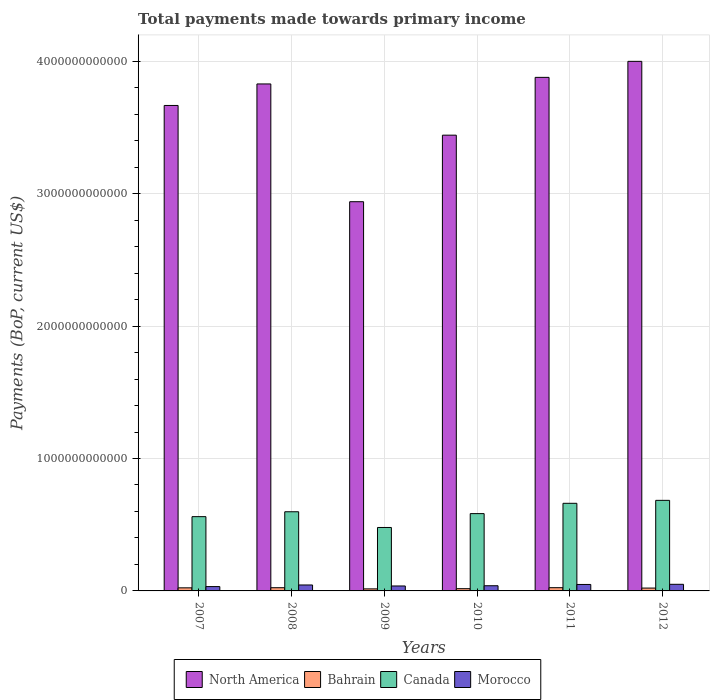How many different coloured bars are there?
Ensure brevity in your answer.  4. How many groups of bars are there?
Provide a short and direct response. 6. Are the number of bars per tick equal to the number of legend labels?
Make the answer very short. Yes. What is the total payments made towards primary income in Canada in 2007?
Ensure brevity in your answer.  5.61e+11. Across all years, what is the maximum total payments made towards primary income in Bahrain?
Provide a short and direct response. 2.45e+1. Across all years, what is the minimum total payments made towards primary income in North America?
Offer a terse response. 2.94e+12. In which year was the total payments made towards primary income in Canada maximum?
Provide a succinct answer. 2012. What is the total total payments made towards primary income in Morocco in the graph?
Provide a succinct answer. 2.53e+11. What is the difference between the total payments made towards primary income in North America in 2009 and that in 2011?
Provide a succinct answer. -9.39e+11. What is the difference between the total payments made towards primary income in Morocco in 2007 and the total payments made towards primary income in North America in 2012?
Give a very brief answer. -3.97e+12. What is the average total payments made towards primary income in Morocco per year?
Your response must be concise. 4.21e+1. In the year 2011, what is the difference between the total payments made towards primary income in Morocco and total payments made towards primary income in Canada?
Your answer should be very brief. -6.13e+11. What is the ratio of the total payments made towards primary income in North America in 2009 to that in 2012?
Make the answer very short. 0.73. Is the difference between the total payments made towards primary income in Morocco in 2007 and 2008 greater than the difference between the total payments made towards primary income in Canada in 2007 and 2008?
Offer a very short reply. Yes. What is the difference between the highest and the second highest total payments made towards primary income in Morocco?
Give a very brief answer. 1.15e+09. What is the difference between the highest and the lowest total payments made towards primary income in Bahrain?
Make the answer very short. 9.04e+09. In how many years, is the total payments made towards primary income in Canada greater than the average total payments made towards primary income in Canada taken over all years?
Offer a very short reply. 3. Is it the case that in every year, the sum of the total payments made towards primary income in Morocco and total payments made towards primary income in North America is greater than the sum of total payments made towards primary income in Bahrain and total payments made towards primary income in Canada?
Keep it short and to the point. Yes. What does the 3rd bar from the left in 2008 represents?
Offer a very short reply. Canada. What does the 2nd bar from the right in 2010 represents?
Offer a very short reply. Canada. Is it the case that in every year, the sum of the total payments made towards primary income in Bahrain and total payments made towards primary income in Canada is greater than the total payments made towards primary income in Morocco?
Give a very brief answer. Yes. How many bars are there?
Ensure brevity in your answer.  24. Are all the bars in the graph horizontal?
Give a very brief answer. No. What is the difference between two consecutive major ticks on the Y-axis?
Provide a succinct answer. 1.00e+12. Are the values on the major ticks of Y-axis written in scientific E-notation?
Your response must be concise. No. How are the legend labels stacked?
Your response must be concise. Horizontal. What is the title of the graph?
Provide a succinct answer. Total payments made towards primary income. Does "Morocco" appear as one of the legend labels in the graph?
Ensure brevity in your answer.  Yes. What is the label or title of the Y-axis?
Ensure brevity in your answer.  Payments (BoP, current US$). What is the Payments (BoP, current US$) of North America in 2007?
Your response must be concise. 3.67e+12. What is the Payments (BoP, current US$) of Bahrain in 2007?
Offer a very short reply. 2.33e+1. What is the Payments (BoP, current US$) of Canada in 2007?
Offer a very short reply. 5.61e+11. What is the Payments (BoP, current US$) of Morocco in 2007?
Your answer should be very brief. 3.27e+1. What is the Payments (BoP, current US$) of North America in 2008?
Give a very brief answer. 3.83e+12. What is the Payments (BoP, current US$) in Bahrain in 2008?
Provide a short and direct response. 2.43e+1. What is the Payments (BoP, current US$) in Canada in 2008?
Your answer should be very brief. 5.98e+11. What is the Payments (BoP, current US$) in Morocco in 2008?
Provide a short and direct response. 4.49e+1. What is the Payments (BoP, current US$) of North America in 2009?
Offer a terse response. 2.94e+12. What is the Payments (BoP, current US$) of Bahrain in 2009?
Provide a short and direct response. 1.54e+1. What is the Payments (BoP, current US$) of Canada in 2009?
Make the answer very short. 4.79e+11. What is the Payments (BoP, current US$) in Morocco in 2009?
Provide a succinct answer. 3.73e+1. What is the Payments (BoP, current US$) of North America in 2010?
Your answer should be compact. 3.44e+12. What is the Payments (BoP, current US$) in Bahrain in 2010?
Make the answer very short. 1.69e+1. What is the Payments (BoP, current US$) in Canada in 2010?
Your answer should be compact. 5.84e+11. What is the Payments (BoP, current US$) in Morocco in 2010?
Make the answer very short. 3.91e+1. What is the Payments (BoP, current US$) of North America in 2011?
Offer a very short reply. 3.88e+12. What is the Payments (BoP, current US$) of Bahrain in 2011?
Your answer should be compact. 2.45e+1. What is the Payments (BoP, current US$) of Canada in 2011?
Your answer should be compact. 6.62e+11. What is the Payments (BoP, current US$) in Morocco in 2011?
Your answer should be compact. 4.88e+1. What is the Payments (BoP, current US$) in North America in 2012?
Keep it short and to the point. 4.00e+12. What is the Payments (BoP, current US$) of Bahrain in 2012?
Your answer should be very brief. 2.16e+1. What is the Payments (BoP, current US$) in Canada in 2012?
Offer a terse response. 6.84e+11. What is the Payments (BoP, current US$) of Morocco in 2012?
Offer a terse response. 4.99e+1. Across all years, what is the maximum Payments (BoP, current US$) of North America?
Your answer should be very brief. 4.00e+12. Across all years, what is the maximum Payments (BoP, current US$) of Bahrain?
Offer a very short reply. 2.45e+1. Across all years, what is the maximum Payments (BoP, current US$) of Canada?
Provide a succinct answer. 6.84e+11. Across all years, what is the maximum Payments (BoP, current US$) of Morocco?
Ensure brevity in your answer.  4.99e+1. Across all years, what is the minimum Payments (BoP, current US$) of North America?
Offer a very short reply. 2.94e+12. Across all years, what is the minimum Payments (BoP, current US$) of Bahrain?
Make the answer very short. 1.54e+1. Across all years, what is the minimum Payments (BoP, current US$) of Canada?
Give a very brief answer. 4.79e+11. Across all years, what is the minimum Payments (BoP, current US$) in Morocco?
Provide a succinct answer. 3.27e+1. What is the total Payments (BoP, current US$) of North America in the graph?
Keep it short and to the point. 2.18e+13. What is the total Payments (BoP, current US$) in Bahrain in the graph?
Provide a succinct answer. 1.26e+11. What is the total Payments (BoP, current US$) of Canada in the graph?
Your response must be concise. 3.57e+12. What is the total Payments (BoP, current US$) of Morocco in the graph?
Your answer should be very brief. 2.53e+11. What is the difference between the Payments (BoP, current US$) of North America in 2007 and that in 2008?
Your response must be concise. -1.62e+11. What is the difference between the Payments (BoP, current US$) in Bahrain in 2007 and that in 2008?
Your answer should be compact. -9.89e+08. What is the difference between the Payments (BoP, current US$) of Canada in 2007 and that in 2008?
Your answer should be compact. -3.69e+1. What is the difference between the Payments (BoP, current US$) of Morocco in 2007 and that in 2008?
Provide a short and direct response. -1.22e+1. What is the difference between the Payments (BoP, current US$) of North America in 2007 and that in 2009?
Offer a terse response. 7.27e+11. What is the difference between the Payments (BoP, current US$) of Bahrain in 2007 and that in 2009?
Your response must be concise. 7.86e+09. What is the difference between the Payments (BoP, current US$) of Canada in 2007 and that in 2009?
Provide a short and direct response. 8.17e+1. What is the difference between the Payments (BoP, current US$) of Morocco in 2007 and that in 2009?
Offer a terse response. -4.61e+09. What is the difference between the Payments (BoP, current US$) in North America in 2007 and that in 2010?
Your answer should be very brief. 2.24e+11. What is the difference between the Payments (BoP, current US$) of Bahrain in 2007 and that in 2010?
Provide a short and direct response. 6.36e+09. What is the difference between the Payments (BoP, current US$) in Canada in 2007 and that in 2010?
Your response must be concise. -2.29e+1. What is the difference between the Payments (BoP, current US$) of Morocco in 2007 and that in 2010?
Make the answer very short. -6.37e+09. What is the difference between the Payments (BoP, current US$) in North America in 2007 and that in 2011?
Your answer should be compact. -2.12e+11. What is the difference between the Payments (BoP, current US$) of Bahrain in 2007 and that in 2011?
Your answer should be very brief. -1.17e+09. What is the difference between the Payments (BoP, current US$) in Canada in 2007 and that in 2011?
Offer a terse response. -1.01e+11. What is the difference between the Payments (BoP, current US$) of Morocco in 2007 and that in 2011?
Your answer should be very brief. -1.60e+1. What is the difference between the Payments (BoP, current US$) in North America in 2007 and that in 2012?
Your answer should be compact. -3.33e+11. What is the difference between the Payments (BoP, current US$) in Bahrain in 2007 and that in 2012?
Your answer should be compact. 1.74e+09. What is the difference between the Payments (BoP, current US$) of Canada in 2007 and that in 2012?
Ensure brevity in your answer.  -1.23e+11. What is the difference between the Payments (BoP, current US$) of Morocco in 2007 and that in 2012?
Your answer should be compact. -1.72e+1. What is the difference between the Payments (BoP, current US$) of North America in 2008 and that in 2009?
Ensure brevity in your answer.  8.89e+11. What is the difference between the Payments (BoP, current US$) in Bahrain in 2008 and that in 2009?
Make the answer very short. 8.85e+09. What is the difference between the Payments (BoP, current US$) of Canada in 2008 and that in 2009?
Provide a succinct answer. 1.19e+11. What is the difference between the Payments (BoP, current US$) in Morocco in 2008 and that in 2009?
Ensure brevity in your answer.  7.56e+09. What is the difference between the Payments (BoP, current US$) of North America in 2008 and that in 2010?
Give a very brief answer. 3.87e+11. What is the difference between the Payments (BoP, current US$) of Bahrain in 2008 and that in 2010?
Your response must be concise. 7.35e+09. What is the difference between the Payments (BoP, current US$) of Canada in 2008 and that in 2010?
Your answer should be very brief. 1.40e+1. What is the difference between the Payments (BoP, current US$) in Morocco in 2008 and that in 2010?
Make the answer very short. 5.80e+09. What is the difference between the Payments (BoP, current US$) of North America in 2008 and that in 2011?
Make the answer very short. -4.97e+1. What is the difference between the Payments (BoP, current US$) of Bahrain in 2008 and that in 2011?
Make the answer very short. -1.82e+08. What is the difference between the Payments (BoP, current US$) in Canada in 2008 and that in 2011?
Your response must be concise. -6.38e+1. What is the difference between the Payments (BoP, current US$) in Morocco in 2008 and that in 2011?
Your response must be concise. -3.85e+09. What is the difference between the Payments (BoP, current US$) in North America in 2008 and that in 2012?
Offer a terse response. -1.71e+11. What is the difference between the Payments (BoP, current US$) of Bahrain in 2008 and that in 2012?
Offer a very short reply. 2.73e+09. What is the difference between the Payments (BoP, current US$) in Canada in 2008 and that in 2012?
Provide a succinct answer. -8.62e+1. What is the difference between the Payments (BoP, current US$) of Morocco in 2008 and that in 2012?
Ensure brevity in your answer.  -5.00e+09. What is the difference between the Payments (BoP, current US$) in North America in 2009 and that in 2010?
Your answer should be compact. -5.02e+11. What is the difference between the Payments (BoP, current US$) in Bahrain in 2009 and that in 2010?
Keep it short and to the point. -1.50e+09. What is the difference between the Payments (BoP, current US$) of Canada in 2009 and that in 2010?
Ensure brevity in your answer.  -1.05e+11. What is the difference between the Payments (BoP, current US$) in Morocco in 2009 and that in 2010?
Your response must be concise. -1.76e+09. What is the difference between the Payments (BoP, current US$) in North America in 2009 and that in 2011?
Your answer should be compact. -9.39e+11. What is the difference between the Payments (BoP, current US$) in Bahrain in 2009 and that in 2011?
Keep it short and to the point. -9.04e+09. What is the difference between the Payments (BoP, current US$) in Canada in 2009 and that in 2011?
Provide a succinct answer. -1.82e+11. What is the difference between the Payments (BoP, current US$) in Morocco in 2009 and that in 2011?
Provide a succinct answer. -1.14e+1. What is the difference between the Payments (BoP, current US$) in North America in 2009 and that in 2012?
Offer a very short reply. -1.06e+12. What is the difference between the Payments (BoP, current US$) in Bahrain in 2009 and that in 2012?
Your answer should be compact. -6.12e+09. What is the difference between the Payments (BoP, current US$) in Canada in 2009 and that in 2012?
Give a very brief answer. -2.05e+11. What is the difference between the Payments (BoP, current US$) of Morocco in 2009 and that in 2012?
Your response must be concise. -1.26e+1. What is the difference between the Payments (BoP, current US$) of North America in 2010 and that in 2011?
Give a very brief answer. -4.37e+11. What is the difference between the Payments (BoP, current US$) in Bahrain in 2010 and that in 2011?
Ensure brevity in your answer.  -7.53e+09. What is the difference between the Payments (BoP, current US$) of Canada in 2010 and that in 2011?
Your answer should be very brief. -7.78e+1. What is the difference between the Payments (BoP, current US$) in Morocco in 2010 and that in 2011?
Your answer should be compact. -9.65e+09. What is the difference between the Payments (BoP, current US$) in North America in 2010 and that in 2012?
Your answer should be very brief. -5.57e+11. What is the difference between the Payments (BoP, current US$) of Bahrain in 2010 and that in 2012?
Your answer should be very brief. -4.62e+09. What is the difference between the Payments (BoP, current US$) in Canada in 2010 and that in 2012?
Make the answer very short. -1.00e+11. What is the difference between the Payments (BoP, current US$) in Morocco in 2010 and that in 2012?
Make the answer very short. -1.08e+1. What is the difference between the Payments (BoP, current US$) of North America in 2011 and that in 2012?
Keep it short and to the point. -1.21e+11. What is the difference between the Payments (BoP, current US$) of Bahrain in 2011 and that in 2012?
Provide a succinct answer. 2.92e+09. What is the difference between the Payments (BoP, current US$) of Canada in 2011 and that in 2012?
Give a very brief answer. -2.23e+1. What is the difference between the Payments (BoP, current US$) of Morocco in 2011 and that in 2012?
Provide a succinct answer. -1.15e+09. What is the difference between the Payments (BoP, current US$) of North America in 2007 and the Payments (BoP, current US$) of Bahrain in 2008?
Give a very brief answer. 3.64e+12. What is the difference between the Payments (BoP, current US$) in North America in 2007 and the Payments (BoP, current US$) in Canada in 2008?
Offer a very short reply. 3.07e+12. What is the difference between the Payments (BoP, current US$) of North America in 2007 and the Payments (BoP, current US$) of Morocco in 2008?
Provide a succinct answer. 3.62e+12. What is the difference between the Payments (BoP, current US$) in Bahrain in 2007 and the Payments (BoP, current US$) in Canada in 2008?
Provide a succinct answer. -5.74e+11. What is the difference between the Payments (BoP, current US$) in Bahrain in 2007 and the Payments (BoP, current US$) in Morocco in 2008?
Offer a terse response. -2.16e+1. What is the difference between the Payments (BoP, current US$) in Canada in 2007 and the Payments (BoP, current US$) in Morocco in 2008?
Make the answer very short. 5.16e+11. What is the difference between the Payments (BoP, current US$) of North America in 2007 and the Payments (BoP, current US$) of Bahrain in 2009?
Make the answer very short. 3.65e+12. What is the difference between the Payments (BoP, current US$) of North America in 2007 and the Payments (BoP, current US$) of Canada in 2009?
Your answer should be compact. 3.19e+12. What is the difference between the Payments (BoP, current US$) of North America in 2007 and the Payments (BoP, current US$) of Morocco in 2009?
Your answer should be compact. 3.63e+12. What is the difference between the Payments (BoP, current US$) of Bahrain in 2007 and the Payments (BoP, current US$) of Canada in 2009?
Your response must be concise. -4.56e+11. What is the difference between the Payments (BoP, current US$) in Bahrain in 2007 and the Payments (BoP, current US$) in Morocco in 2009?
Offer a very short reply. -1.40e+1. What is the difference between the Payments (BoP, current US$) of Canada in 2007 and the Payments (BoP, current US$) of Morocco in 2009?
Make the answer very short. 5.24e+11. What is the difference between the Payments (BoP, current US$) of North America in 2007 and the Payments (BoP, current US$) of Bahrain in 2010?
Your response must be concise. 3.65e+12. What is the difference between the Payments (BoP, current US$) of North America in 2007 and the Payments (BoP, current US$) of Canada in 2010?
Your answer should be compact. 3.08e+12. What is the difference between the Payments (BoP, current US$) of North America in 2007 and the Payments (BoP, current US$) of Morocco in 2010?
Make the answer very short. 3.63e+12. What is the difference between the Payments (BoP, current US$) of Bahrain in 2007 and the Payments (BoP, current US$) of Canada in 2010?
Offer a very short reply. -5.60e+11. What is the difference between the Payments (BoP, current US$) in Bahrain in 2007 and the Payments (BoP, current US$) in Morocco in 2010?
Keep it short and to the point. -1.58e+1. What is the difference between the Payments (BoP, current US$) of Canada in 2007 and the Payments (BoP, current US$) of Morocco in 2010?
Offer a terse response. 5.22e+11. What is the difference between the Payments (BoP, current US$) of North America in 2007 and the Payments (BoP, current US$) of Bahrain in 2011?
Your response must be concise. 3.64e+12. What is the difference between the Payments (BoP, current US$) in North America in 2007 and the Payments (BoP, current US$) in Canada in 2011?
Give a very brief answer. 3.00e+12. What is the difference between the Payments (BoP, current US$) of North America in 2007 and the Payments (BoP, current US$) of Morocco in 2011?
Provide a short and direct response. 3.62e+12. What is the difference between the Payments (BoP, current US$) of Bahrain in 2007 and the Payments (BoP, current US$) of Canada in 2011?
Your response must be concise. -6.38e+11. What is the difference between the Payments (BoP, current US$) of Bahrain in 2007 and the Payments (BoP, current US$) of Morocco in 2011?
Provide a succinct answer. -2.55e+1. What is the difference between the Payments (BoP, current US$) of Canada in 2007 and the Payments (BoP, current US$) of Morocco in 2011?
Provide a succinct answer. 5.12e+11. What is the difference between the Payments (BoP, current US$) of North America in 2007 and the Payments (BoP, current US$) of Bahrain in 2012?
Your answer should be very brief. 3.64e+12. What is the difference between the Payments (BoP, current US$) of North America in 2007 and the Payments (BoP, current US$) of Canada in 2012?
Ensure brevity in your answer.  2.98e+12. What is the difference between the Payments (BoP, current US$) in North America in 2007 and the Payments (BoP, current US$) in Morocco in 2012?
Your answer should be compact. 3.62e+12. What is the difference between the Payments (BoP, current US$) in Bahrain in 2007 and the Payments (BoP, current US$) in Canada in 2012?
Offer a very short reply. -6.61e+11. What is the difference between the Payments (BoP, current US$) of Bahrain in 2007 and the Payments (BoP, current US$) of Morocco in 2012?
Provide a succinct answer. -2.66e+1. What is the difference between the Payments (BoP, current US$) in Canada in 2007 and the Payments (BoP, current US$) in Morocco in 2012?
Your answer should be compact. 5.11e+11. What is the difference between the Payments (BoP, current US$) of North America in 2008 and the Payments (BoP, current US$) of Bahrain in 2009?
Make the answer very short. 3.81e+12. What is the difference between the Payments (BoP, current US$) in North America in 2008 and the Payments (BoP, current US$) in Canada in 2009?
Give a very brief answer. 3.35e+12. What is the difference between the Payments (BoP, current US$) in North America in 2008 and the Payments (BoP, current US$) in Morocco in 2009?
Keep it short and to the point. 3.79e+12. What is the difference between the Payments (BoP, current US$) of Bahrain in 2008 and the Payments (BoP, current US$) of Canada in 2009?
Offer a very short reply. -4.55e+11. What is the difference between the Payments (BoP, current US$) in Bahrain in 2008 and the Payments (BoP, current US$) in Morocco in 2009?
Offer a very short reply. -1.31e+1. What is the difference between the Payments (BoP, current US$) in Canada in 2008 and the Payments (BoP, current US$) in Morocco in 2009?
Make the answer very short. 5.60e+11. What is the difference between the Payments (BoP, current US$) of North America in 2008 and the Payments (BoP, current US$) of Bahrain in 2010?
Offer a very short reply. 3.81e+12. What is the difference between the Payments (BoP, current US$) in North America in 2008 and the Payments (BoP, current US$) in Canada in 2010?
Provide a short and direct response. 3.24e+12. What is the difference between the Payments (BoP, current US$) of North America in 2008 and the Payments (BoP, current US$) of Morocco in 2010?
Offer a terse response. 3.79e+12. What is the difference between the Payments (BoP, current US$) of Bahrain in 2008 and the Payments (BoP, current US$) of Canada in 2010?
Provide a short and direct response. -5.60e+11. What is the difference between the Payments (BoP, current US$) of Bahrain in 2008 and the Payments (BoP, current US$) of Morocco in 2010?
Ensure brevity in your answer.  -1.48e+1. What is the difference between the Payments (BoP, current US$) of Canada in 2008 and the Payments (BoP, current US$) of Morocco in 2010?
Your response must be concise. 5.59e+11. What is the difference between the Payments (BoP, current US$) in North America in 2008 and the Payments (BoP, current US$) in Bahrain in 2011?
Your answer should be compact. 3.80e+12. What is the difference between the Payments (BoP, current US$) of North America in 2008 and the Payments (BoP, current US$) of Canada in 2011?
Give a very brief answer. 3.17e+12. What is the difference between the Payments (BoP, current US$) of North America in 2008 and the Payments (BoP, current US$) of Morocco in 2011?
Your answer should be very brief. 3.78e+12. What is the difference between the Payments (BoP, current US$) of Bahrain in 2008 and the Payments (BoP, current US$) of Canada in 2011?
Provide a succinct answer. -6.37e+11. What is the difference between the Payments (BoP, current US$) of Bahrain in 2008 and the Payments (BoP, current US$) of Morocco in 2011?
Give a very brief answer. -2.45e+1. What is the difference between the Payments (BoP, current US$) of Canada in 2008 and the Payments (BoP, current US$) of Morocco in 2011?
Offer a terse response. 5.49e+11. What is the difference between the Payments (BoP, current US$) of North America in 2008 and the Payments (BoP, current US$) of Bahrain in 2012?
Give a very brief answer. 3.81e+12. What is the difference between the Payments (BoP, current US$) in North America in 2008 and the Payments (BoP, current US$) in Canada in 2012?
Your response must be concise. 3.14e+12. What is the difference between the Payments (BoP, current US$) of North America in 2008 and the Payments (BoP, current US$) of Morocco in 2012?
Your answer should be compact. 3.78e+12. What is the difference between the Payments (BoP, current US$) in Bahrain in 2008 and the Payments (BoP, current US$) in Canada in 2012?
Your answer should be compact. -6.60e+11. What is the difference between the Payments (BoP, current US$) in Bahrain in 2008 and the Payments (BoP, current US$) in Morocco in 2012?
Make the answer very short. -2.56e+1. What is the difference between the Payments (BoP, current US$) in Canada in 2008 and the Payments (BoP, current US$) in Morocco in 2012?
Make the answer very short. 5.48e+11. What is the difference between the Payments (BoP, current US$) of North America in 2009 and the Payments (BoP, current US$) of Bahrain in 2010?
Give a very brief answer. 2.92e+12. What is the difference between the Payments (BoP, current US$) in North America in 2009 and the Payments (BoP, current US$) in Canada in 2010?
Provide a short and direct response. 2.36e+12. What is the difference between the Payments (BoP, current US$) in North America in 2009 and the Payments (BoP, current US$) in Morocco in 2010?
Give a very brief answer. 2.90e+12. What is the difference between the Payments (BoP, current US$) in Bahrain in 2009 and the Payments (BoP, current US$) in Canada in 2010?
Your answer should be very brief. -5.68e+11. What is the difference between the Payments (BoP, current US$) of Bahrain in 2009 and the Payments (BoP, current US$) of Morocco in 2010?
Keep it short and to the point. -2.37e+1. What is the difference between the Payments (BoP, current US$) in Canada in 2009 and the Payments (BoP, current US$) in Morocco in 2010?
Offer a very short reply. 4.40e+11. What is the difference between the Payments (BoP, current US$) in North America in 2009 and the Payments (BoP, current US$) in Bahrain in 2011?
Provide a short and direct response. 2.91e+12. What is the difference between the Payments (BoP, current US$) of North America in 2009 and the Payments (BoP, current US$) of Canada in 2011?
Offer a terse response. 2.28e+12. What is the difference between the Payments (BoP, current US$) of North America in 2009 and the Payments (BoP, current US$) of Morocco in 2011?
Ensure brevity in your answer.  2.89e+12. What is the difference between the Payments (BoP, current US$) of Bahrain in 2009 and the Payments (BoP, current US$) of Canada in 2011?
Keep it short and to the point. -6.46e+11. What is the difference between the Payments (BoP, current US$) of Bahrain in 2009 and the Payments (BoP, current US$) of Morocco in 2011?
Give a very brief answer. -3.33e+1. What is the difference between the Payments (BoP, current US$) of Canada in 2009 and the Payments (BoP, current US$) of Morocco in 2011?
Provide a short and direct response. 4.30e+11. What is the difference between the Payments (BoP, current US$) of North America in 2009 and the Payments (BoP, current US$) of Bahrain in 2012?
Offer a terse response. 2.92e+12. What is the difference between the Payments (BoP, current US$) in North America in 2009 and the Payments (BoP, current US$) in Canada in 2012?
Your response must be concise. 2.26e+12. What is the difference between the Payments (BoP, current US$) in North America in 2009 and the Payments (BoP, current US$) in Morocco in 2012?
Keep it short and to the point. 2.89e+12. What is the difference between the Payments (BoP, current US$) in Bahrain in 2009 and the Payments (BoP, current US$) in Canada in 2012?
Your answer should be compact. -6.69e+11. What is the difference between the Payments (BoP, current US$) of Bahrain in 2009 and the Payments (BoP, current US$) of Morocco in 2012?
Your response must be concise. -3.45e+1. What is the difference between the Payments (BoP, current US$) of Canada in 2009 and the Payments (BoP, current US$) of Morocco in 2012?
Offer a terse response. 4.29e+11. What is the difference between the Payments (BoP, current US$) of North America in 2010 and the Payments (BoP, current US$) of Bahrain in 2011?
Give a very brief answer. 3.42e+12. What is the difference between the Payments (BoP, current US$) of North America in 2010 and the Payments (BoP, current US$) of Canada in 2011?
Keep it short and to the point. 2.78e+12. What is the difference between the Payments (BoP, current US$) in North America in 2010 and the Payments (BoP, current US$) in Morocco in 2011?
Ensure brevity in your answer.  3.39e+12. What is the difference between the Payments (BoP, current US$) in Bahrain in 2010 and the Payments (BoP, current US$) in Canada in 2011?
Make the answer very short. -6.45e+11. What is the difference between the Payments (BoP, current US$) in Bahrain in 2010 and the Payments (BoP, current US$) in Morocco in 2011?
Make the answer very short. -3.18e+1. What is the difference between the Payments (BoP, current US$) of Canada in 2010 and the Payments (BoP, current US$) of Morocco in 2011?
Your response must be concise. 5.35e+11. What is the difference between the Payments (BoP, current US$) in North America in 2010 and the Payments (BoP, current US$) in Bahrain in 2012?
Ensure brevity in your answer.  3.42e+12. What is the difference between the Payments (BoP, current US$) in North America in 2010 and the Payments (BoP, current US$) in Canada in 2012?
Give a very brief answer. 2.76e+12. What is the difference between the Payments (BoP, current US$) of North America in 2010 and the Payments (BoP, current US$) of Morocco in 2012?
Give a very brief answer. 3.39e+12. What is the difference between the Payments (BoP, current US$) of Bahrain in 2010 and the Payments (BoP, current US$) of Canada in 2012?
Ensure brevity in your answer.  -6.67e+11. What is the difference between the Payments (BoP, current US$) in Bahrain in 2010 and the Payments (BoP, current US$) in Morocco in 2012?
Provide a short and direct response. -3.30e+1. What is the difference between the Payments (BoP, current US$) of Canada in 2010 and the Payments (BoP, current US$) of Morocco in 2012?
Your answer should be very brief. 5.34e+11. What is the difference between the Payments (BoP, current US$) of North America in 2011 and the Payments (BoP, current US$) of Bahrain in 2012?
Your response must be concise. 3.86e+12. What is the difference between the Payments (BoP, current US$) of North America in 2011 and the Payments (BoP, current US$) of Canada in 2012?
Offer a very short reply. 3.19e+12. What is the difference between the Payments (BoP, current US$) in North America in 2011 and the Payments (BoP, current US$) in Morocco in 2012?
Provide a short and direct response. 3.83e+12. What is the difference between the Payments (BoP, current US$) of Bahrain in 2011 and the Payments (BoP, current US$) of Canada in 2012?
Your answer should be compact. -6.59e+11. What is the difference between the Payments (BoP, current US$) of Bahrain in 2011 and the Payments (BoP, current US$) of Morocco in 2012?
Ensure brevity in your answer.  -2.54e+1. What is the difference between the Payments (BoP, current US$) of Canada in 2011 and the Payments (BoP, current US$) of Morocco in 2012?
Your response must be concise. 6.12e+11. What is the average Payments (BoP, current US$) in North America per year?
Keep it short and to the point. 3.63e+12. What is the average Payments (BoP, current US$) in Bahrain per year?
Your answer should be compact. 2.10e+1. What is the average Payments (BoP, current US$) in Canada per year?
Your answer should be very brief. 5.95e+11. What is the average Payments (BoP, current US$) of Morocco per year?
Provide a short and direct response. 4.21e+1. In the year 2007, what is the difference between the Payments (BoP, current US$) of North America and Payments (BoP, current US$) of Bahrain?
Keep it short and to the point. 3.64e+12. In the year 2007, what is the difference between the Payments (BoP, current US$) in North America and Payments (BoP, current US$) in Canada?
Offer a terse response. 3.11e+12. In the year 2007, what is the difference between the Payments (BoP, current US$) in North America and Payments (BoP, current US$) in Morocco?
Ensure brevity in your answer.  3.63e+12. In the year 2007, what is the difference between the Payments (BoP, current US$) in Bahrain and Payments (BoP, current US$) in Canada?
Your response must be concise. -5.38e+11. In the year 2007, what is the difference between the Payments (BoP, current US$) in Bahrain and Payments (BoP, current US$) in Morocco?
Your response must be concise. -9.44e+09. In the year 2007, what is the difference between the Payments (BoP, current US$) of Canada and Payments (BoP, current US$) of Morocco?
Offer a terse response. 5.28e+11. In the year 2008, what is the difference between the Payments (BoP, current US$) in North America and Payments (BoP, current US$) in Bahrain?
Provide a succinct answer. 3.80e+12. In the year 2008, what is the difference between the Payments (BoP, current US$) in North America and Payments (BoP, current US$) in Canada?
Provide a succinct answer. 3.23e+12. In the year 2008, what is the difference between the Payments (BoP, current US$) in North America and Payments (BoP, current US$) in Morocco?
Offer a terse response. 3.78e+12. In the year 2008, what is the difference between the Payments (BoP, current US$) of Bahrain and Payments (BoP, current US$) of Canada?
Provide a succinct answer. -5.73e+11. In the year 2008, what is the difference between the Payments (BoP, current US$) of Bahrain and Payments (BoP, current US$) of Morocco?
Your response must be concise. -2.06e+1. In the year 2008, what is the difference between the Payments (BoP, current US$) of Canada and Payments (BoP, current US$) of Morocco?
Provide a succinct answer. 5.53e+11. In the year 2009, what is the difference between the Payments (BoP, current US$) in North America and Payments (BoP, current US$) in Bahrain?
Offer a very short reply. 2.92e+12. In the year 2009, what is the difference between the Payments (BoP, current US$) in North America and Payments (BoP, current US$) in Canada?
Offer a terse response. 2.46e+12. In the year 2009, what is the difference between the Payments (BoP, current US$) of North America and Payments (BoP, current US$) of Morocco?
Give a very brief answer. 2.90e+12. In the year 2009, what is the difference between the Payments (BoP, current US$) of Bahrain and Payments (BoP, current US$) of Canada?
Ensure brevity in your answer.  -4.64e+11. In the year 2009, what is the difference between the Payments (BoP, current US$) of Bahrain and Payments (BoP, current US$) of Morocco?
Make the answer very short. -2.19e+1. In the year 2009, what is the difference between the Payments (BoP, current US$) in Canada and Payments (BoP, current US$) in Morocco?
Offer a terse response. 4.42e+11. In the year 2010, what is the difference between the Payments (BoP, current US$) of North America and Payments (BoP, current US$) of Bahrain?
Keep it short and to the point. 3.42e+12. In the year 2010, what is the difference between the Payments (BoP, current US$) of North America and Payments (BoP, current US$) of Canada?
Your answer should be very brief. 2.86e+12. In the year 2010, what is the difference between the Payments (BoP, current US$) of North America and Payments (BoP, current US$) of Morocco?
Keep it short and to the point. 3.40e+12. In the year 2010, what is the difference between the Payments (BoP, current US$) of Bahrain and Payments (BoP, current US$) of Canada?
Your response must be concise. -5.67e+11. In the year 2010, what is the difference between the Payments (BoP, current US$) in Bahrain and Payments (BoP, current US$) in Morocco?
Offer a terse response. -2.22e+1. In the year 2010, what is the difference between the Payments (BoP, current US$) of Canada and Payments (BoP, current US$) of Morocco?
Provide a short and direct response. 5.45e+11. In the year 2011, what is the difference between the Payments (BoP, current US$) in North America and Payments (BoP, current US$) in Bahrain?
Offer a very short reply. 3.85e+12. In the year 2011, what is the difference between the Payments (BoP, current US$) of North America and Payments (BoP, current US$) of Canada?
Offer a terse response. 3.22e+12. In the year 2011, what is the difference between the Payments (BoP, current US$) of North America and Payments (BoP, current US$) of Morocco?
Provide a succinct answer. 3.83e+12. In the year 2011, what is the difference between the Payments (BoP, current US$) of Bahrain and Payments (BoP, current US$) of Canada?
Keep it short and to the point. -6.37e+11. In the year 2011, what is the difference between the Payments (BoP, current US$) in Bahrain and Payments (BoP, current US$) in Morocco?
Make the answer very short. -2.43e+1. In the year 2011, what is the difference between the Payments (BoP, current US$) in Canada and Payments (BoP, current US$) in Morocco?
Provide a succinct answer. 6.13e+11. In the year 2012, what is the difference between the Payments (BoP, current US$) of North America and Payments (BoP, current US$) of Bahrain?
Provide a short and direct response. 3.98e+12. In the year 2012, what is the difference between the Payments (BoP, current US$) in North America and Payments (BoP, current US$) in Canada?
Your answer should be very brief. 3.32e+12. In the year 2012, what is the difference between the Payments (BoP, current US$) of North America and Payments (BoP, current US$) of Morocco?
Your answer should be very brief. 3.95e+12. In the year 2012, what is the difference between the Payments (BoP, current US$) of Bahrain and Payments (BoP, current US$) of Canada?
Your response must be concise. -6.62e+11. In the year 2012, what is the difference between the Payments (BoP, current US$) in Bahrain and Payments (BoP, current US$) in Morocco?
Provide a short and direct response. -2.84e+1. In the year 2012, what is the difference between the Payments (BoP, current US$) of Canada and Payments (BoP, current US$) of Morocco?
Your answer should be compact. 6.34e+11. What is the ratio of the Payments (BoP, current US$) of North America in 2007 to that in 2008?
Make the answer very short. 0.96. What is the ratio of the Payments (BoP, current US$) of Bahrain in 2007 to that in 2008?
Make the answer very short. 0.96. What is the ratio of the Payments (BoP, current US$) of Canada in 2007 to that in 2008?
Provide a short and direct response. 0.94. What is the ratio of the Payments (BoP, current US$) of Morocco in 2007 to that in 2008?
Make the answer very short. 0.73. What is the ratio of the Payments (BoP, current US$) in North America in 2007 to that in 2009?
Provide a succinct answer. 1.25. What is the ratio of the Payments (BoP, current US$) in Bahrain in 2007 to that in 2009?
Your answer should be very brief. 1.51. What is the ratio of the Payments (BoP, current US$) of Canada in 2007 to that in 2009?
Offer a very short reply. 1.17. What is the ratio of the Payments (BoP, current US$) in Morocco in 2007 to that in 2009?
Keep it short and to the point. 0.88. What is the ratio of the Payments (BoP, current US$) of North America in 2007 to that in 2010?
Your answer should be very brief. 1.07. What is the ratio of the Payments (BoP, current US$) in Bahrain in 2007 to that in 2010?
Your response must be concise. 1.38. What is the ratio of the Payments (BoP, current US$) in Canada in 2007 to that in 2010?
Your answer should be very brief. 0.96. What is the ratio of the Payments (BoP, current US$) of Morocco in 2007 to that in 2010?
Provide a succinct answer. 0.84. What is the ratio of the Payments (BoP, current US$) in North America in 2007 to that in 2011?
Your answer should be compact. 0.95. What is the ratio of the Payments (BoP, current US$) of Bahrain in 2007 to that in 2011?
Provide a succinct answer. 0.95. What is the ratio of the Payments (BoP, current US$) of Canada in 2007 to that in 2011?
Make the answer very short. 0.85. What is the ratio of the Payments (BoP, current US$) of Morocco in 2007 to that in 2011?
Give a very brief answer. 0.67. What is the ratio of the Payments (BoP, current US$) in Bahrain in 2007 to that in 2012?
Your response must be concise. 1.08. What is the ratio of the Payments (BoP, current US$) in Canada in 2007 to that in 2012?
Provide a short and direct response. 0.82. What is the ratio of the Payments (BoP, current US$) of Morocco in 2007 to that in 2012?
Provide a short and direct response. 0.66. What is the ratio of the Payments (BoP, current US$) of North America in 2008 to that in 2009?
Your response must be concise. 1.3. What is the ratio of the Payments (BoP, current US$) in Bahrain in 2008 to that in 2009?
Ensure brevity in your answer.  1.57. What is the ratio of the Payments (BoP, current US$) in Canada in 2008 to that in 2009?
Ensure brevity in your answer.  1.25. What is the ratio of the Payments (BoP, current US$) of Morocco in 2008 to that in 2009?
Offer a very short reply. 1.2. What is the ratio of the Payments (BoP, current US$) in North America in 2008 to that in 2010?
Offer a very short reply. 1.11. What is the ratio of the Payments (BoP, current US$) in Bahrain in 2008 to that in 2010?
Your answer should be compact. 1.43. What is the ratio of the Payments (BoP, current US$) in Canada in 2008 to that in 2010?
Ensure brevity in your answer.  1.02. What is the ratio of the Payments (BoP, current US$) in Morocco in 2008 to that in 2010?
Give a very brief answer. 1.15. What is the ratio of the Payments (BoP, current US$) in North America in 2008 to that in 2011?
Ensure brevity in your answer.  0.99. What is the ratio of the Payments (BoP, current US$) in Canada in 2008 to that in 2011?
Your answer should be compact. 0.9. What is the ratio of the Payments (BoP, current US$) in Morocco in 2008 to that in 2011?
Your answer should be very brief. 0.92. What is the ratio of the Payments (BoP, current US$) in North America in 2008 to that in 2012?
Make the answer very short. 0.96. What is the ratio of the Payments (BoP, current US$) in Bahrain in 2008 to that in 2012?
Your answer should be compact. 1.13. What is the ratio of the Payments (BoP, current US$) of Canada in 2008 to that in 2012?
Provide a short and direct response. 0.87. What is the ratio of the Payments (BoP, current US$) of Morocco in 2008 to that in 2012?
Provide a short and direct response. 0.9. What is the ratio of the Payments (BoP, current US$) of North America in 2009 to that in 2010?
Offer a very short reply. 0.85. What is the ratio of the Payments (BoP, current US$) in Bahrain in 2009 to that in 2010?
Ensure brevity in your answer.  0.91. What is the ratio of the Payments (BoP, current US$) of Canada in 2009 to that in 2010?
Your response must be concise. 0.82. What is the ratio of the Payments (BoP, current US$) of Morocco in 2009 to that in 2010?
Your answer should be very brief. 0.95. What is the ratio of the Payments (BoP, current US$) of North America in 2009 to that in 2011?
Keep it short and to the point. 0.76. What is the ratio of the Payments (BoP, current US$) of Bahrain in 2009 to that in 2011?
Give a very brief answer. 0.63. What is the ratio of the Payments (BoP, current US$) of Canada in 2009 to that in 2011?
Provide a succinct answer. 0.72. What is the ratio of the Payments (BoP, current US$) of Morocco in 2009 to that in 2011?
Keep it short and to the point. 0.77. What is the ratio of the Payments (BoP, current US$) in North America in 2009 to that in 2012?
Offer a very short reply. 0.73. What is the ratio of the Payments (BoP, current US$) of Bahrain in 2009 to that in 2012?
Your answer should be compact. 0.72. What is the ratio of the Payments (BoP, current US$) of Canada in 2009 to that in 2012?
Keep it short and to the point. 0.7. What is the ratio of the Payments (BoP, current US$) of Morocco in 2009 to that in 2012?
Make the answer very short. 0.75. What is the ratio of the Payments (BoP, current US$) of North America in 2010 to that in 2011?
Your response must be concise. 0.89. What is the ratio of the Payments (BoP, current US$) of Bahrain in 2010 to that in 2011?
Your response must be concise. 0.69. What is the ratio of the Payments (BoP, current US$) in Canada in 2010 to that in 2011?
Offer a very short reply. 0.88. What is the ratio of the Payments (BoP, current US$) in Morocco in 2010 to that in 2011?
Give a very brief answer. 0.8. What is the ratio of the Payments (BoP, current US$) in North America in 2010 to that in 2012?
Provide a short and direct response. 0.86. What is the ratio of the Payments (BoP, current US$) of Bahrain in 2010 to that in 2012?
Your answer should be very brief. 0.79. What is the ratio of the Payments (BoP, current US$) of Canada in 2010 to that in 2012?
Offer a very short reply. 0.85. What is the ratio of the Payments (BoP, current US$) of Morocco in 2010 to that in 2012?
Your response must be concise. 0.78. What is the ratio of the Payments (BoP, current US$) of North America in 2011 to that in 2012?
Keep it short and to the point. 0.97. What is the ratio of the Payments (BoP, current US$) in Bahrain in 2011 to that in 2012?
Provide a succinct answer. 1.14. What is the ratio of the Payments (BoP, current US$) in Canada in 2011 to that in 2012?
Keep it short and to the point. 0.97. What is the difference between the highest and the second highest Payments (BoP, current US$) of North America?
Give a very brief answer. 1.21e+11. What is the difference between the highest and the second highest Payments (BoP, current US$) of Bahrain?
Make the answer very short. 1.82e+08. What is the difference between the highest and the second highest Payments (BoP, current US$) of Canada?
Make the answer very short. 2.23e+1. What is the difference between the highest and the second highest Payments (BoP, current US$) of Morocco?
Offer a terse response. 1.15e+09. What is the difference between the highest and the lowest Payments (BoP, current US$) of North America?
Give a very brief answer. 1.06e+12. What is the difference between the highest and the lowest Payments (BoP, current US$) in Bahrain?
Keep it short and to the point. 9.04e+09. What is the difference between the highest and the lowest Payments (BoP, current US$) in Canada?
Offer a terse response. 2.05e+11. What is the difference between the highest and the lowest Payments (BoP, current US$) of Morocco?
Offer a terse response. 1.72e+1. 